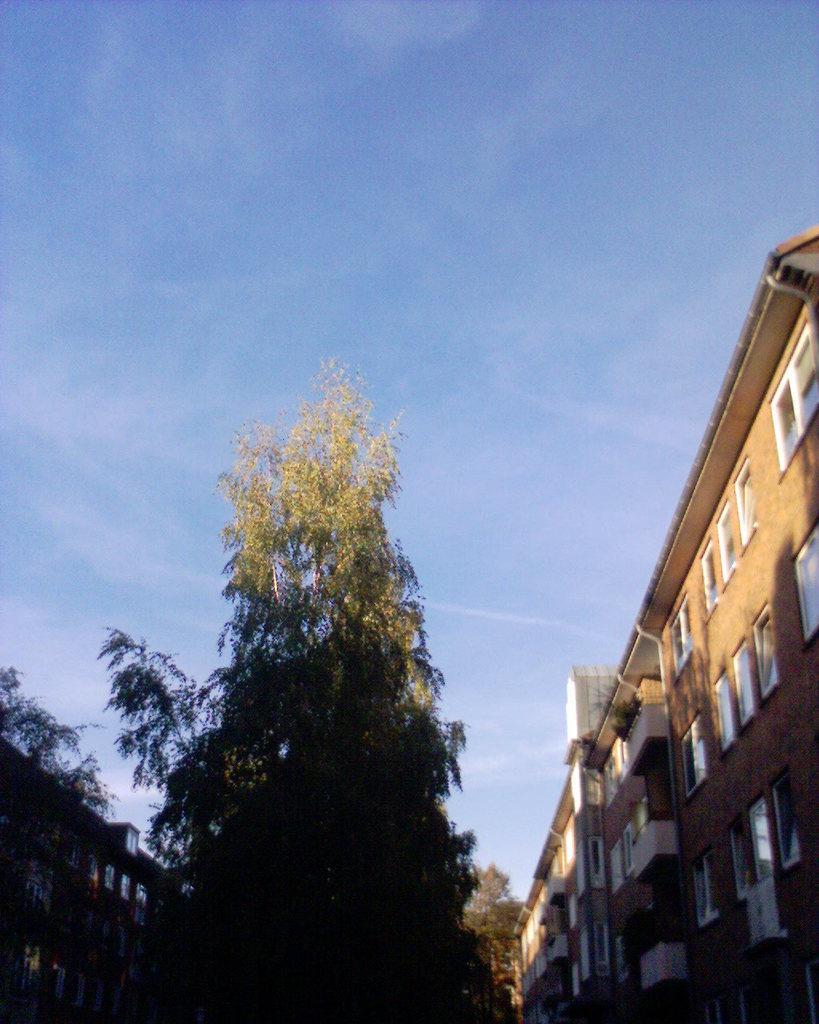Describe this image in one or two sentences. In the middle of this image, there is a tree. On the left side, there is a building which is having windows. On the right side, there is another building, which is having windows. In the background, there are trees and there are clouds in the blue sky. 